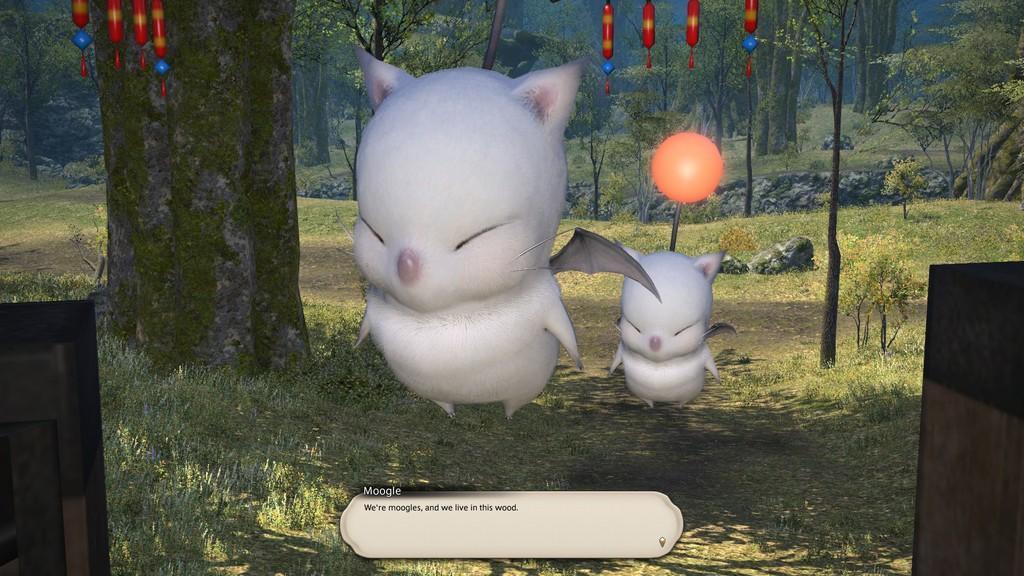Describe this image in one or two sentences. This is an an animated image. In this image I can see two birds which are in white color. I can see few red color objects and many trees in the back. 